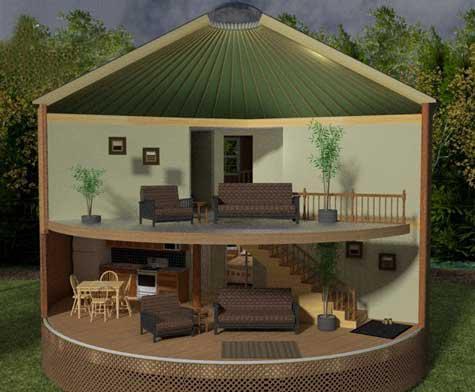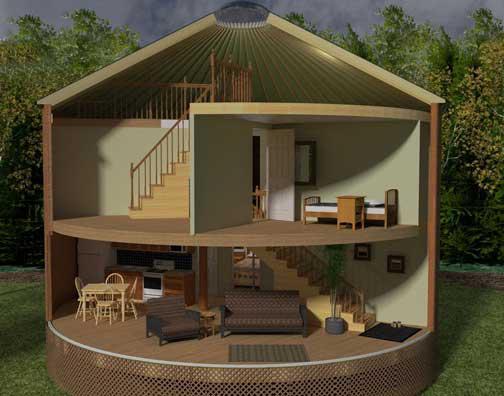The first image is the image on the left, the second image is the image on the right. Assess this claim about the two images: "The interior is shown of the hut in at least one of the images.". Correct or not? Answer yes or no. Yes. The first image is the image on the left, the second image is the image on the right. Given the left and right images, does the statement "At least one image shows a model of a circular building, with a section removed to show the interior." hold true? Answer yes or no. Yes. 